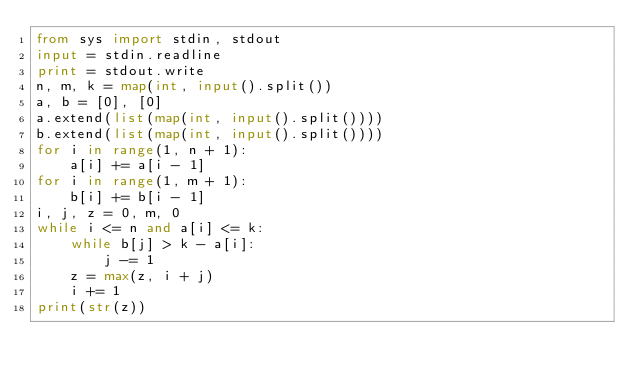<code> <loc_0><loc_0><loc_500><loc_500><_Python_>from sys import stdin, stdout
input = stdin.readline
print = stdout.write
n, m, k = map(int, input().split())
a, b = [0], [0]
a.extend(list(map(int, input().split())))
b.extend(list(map(int, input().split())))
for i in range(1, n + 1):
    a[i] += a[i - 1]
for i in range(1, m + 1):
    b[i] += b[i - 1]
i, j, z = 0, m, 0
while i <= n and a[i] <= k:
    while b[j] > k - a[i]:
        j -= 1
    z = max(z, i + j)
    i += 1
print(str(z))</code> 